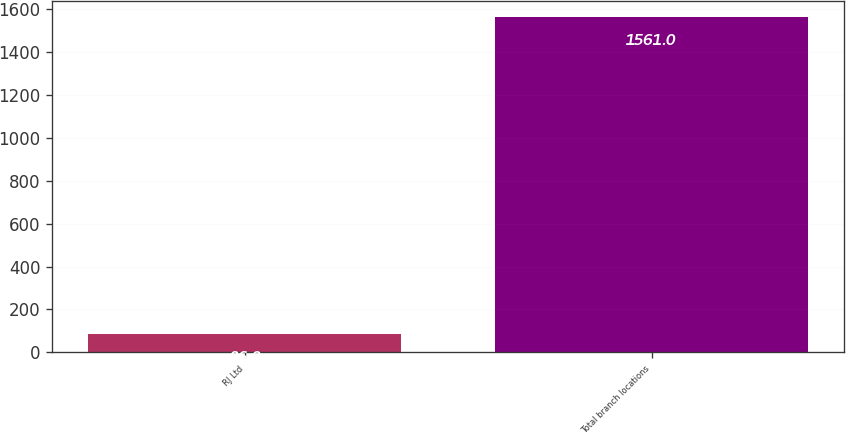<chart> <loc_0><loc_0><loc_500><loc_500><bar_chart><fcel>RJ Ltd<fcel>Total branch locations<nl><fcel>86<fcel>1561<nl></chart> 